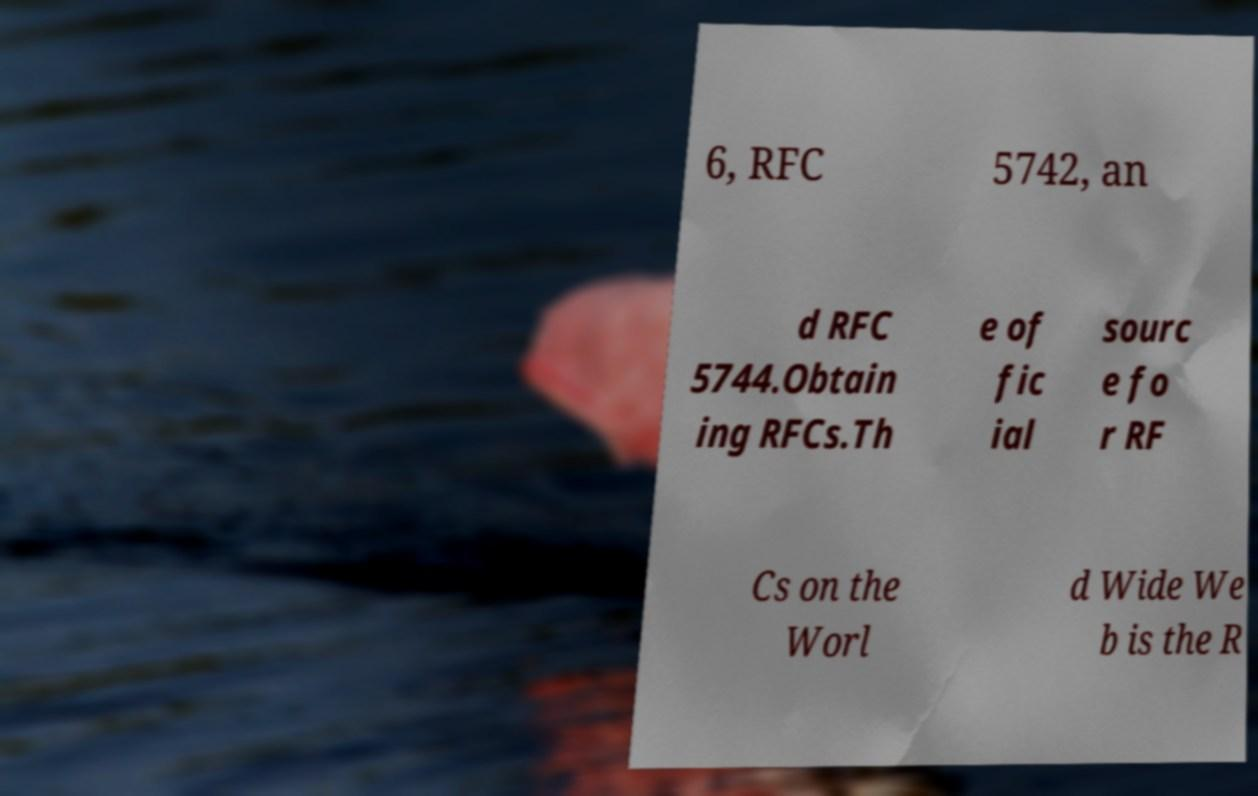Could you extract and type out the text from this image? 6, RFC 5742, an d RFC 5744.Obtain ing RFCs.Th e of fic ial sourc e fo r RF Cs on the Worl d Wide We b is the R 